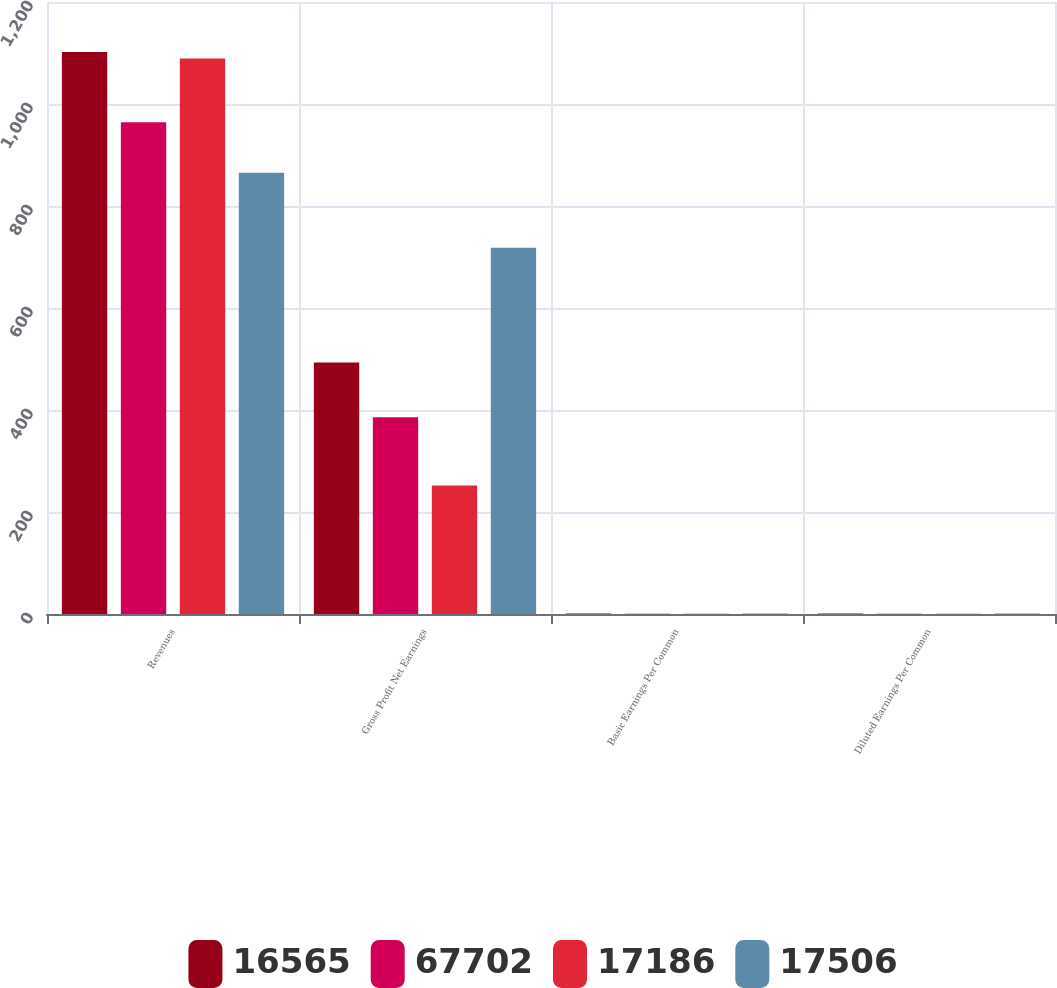Convert chart to OTSL. <chart><loc_0><loc_0><loc_500><loc_500><stacked_bar_chart><ecel><fcel>Revenues<fcel>Gross Profit Net Earnings<fcel>Basic Earnings Per Common<fcel>Diluted Earnings Per Common<nl><fcel>16565<fcel>1102<fcel>493<fcel>0.78<fcel>0.77<nl><fcel>67702<fcel>964<fcel>386<fcel>0.62<fcel>0.62<nl><fcel>17186<fcel>1089<fcel>252<fcel>0.41<fcel>0.41<nl><fcel>17506<fcel>865<fcel>718<fcel>1.2<fcel>1.19<nl></chart> 